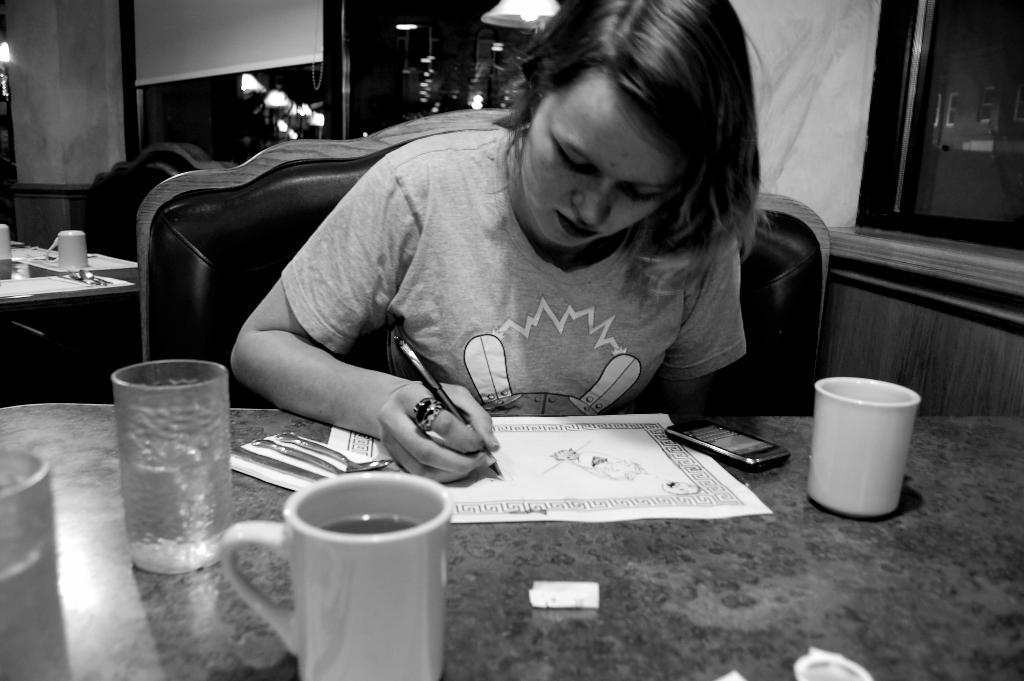Please provide a concise description of this image. in this picture we can find a woman sitting in the chair near the table and writing something on a paper, on the table we can find mobile phone, glass, cups, and few things. In the background we can also find a table, a chair, a cup on the table and windows, lights. 